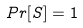Convert formula to latex. <formula><loc_0><loc_0><loc_500><loc_500>P r [ S ] = 1</formula> 